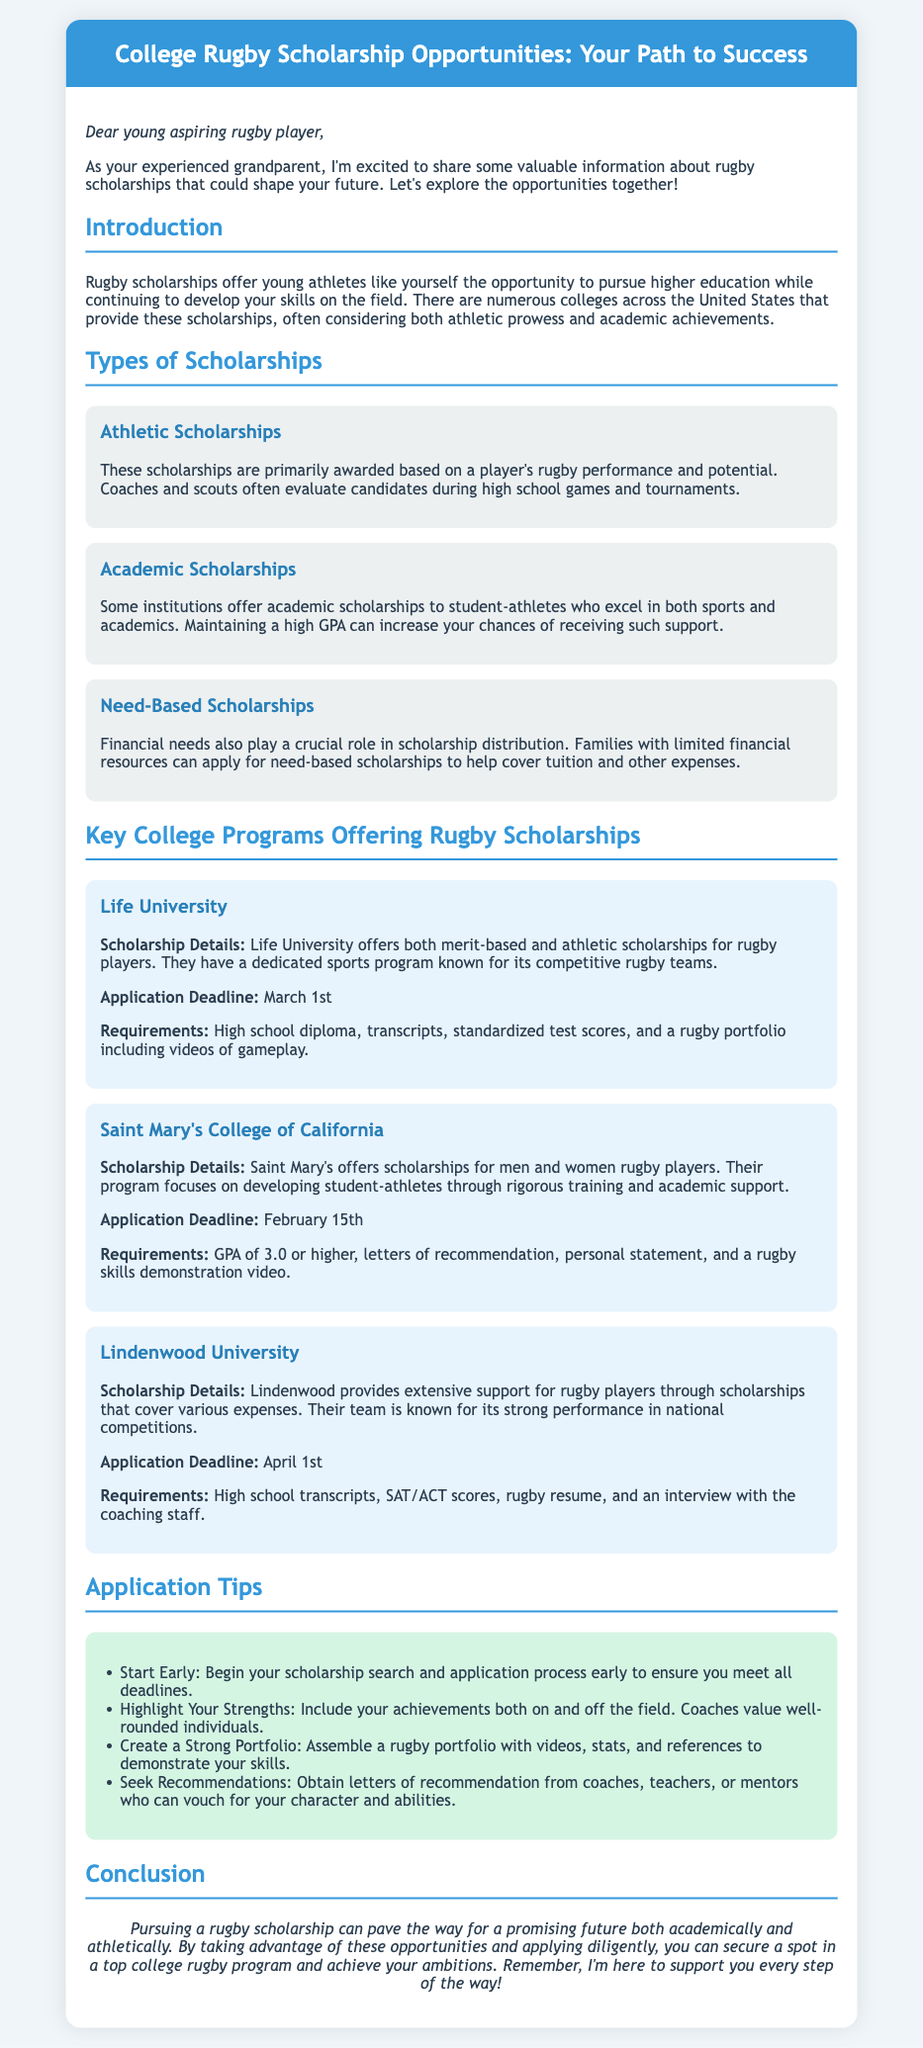What is the application deadline for Life University? The application deadline for Life University is mentioned in the document, specifically noted under the scholarship details.
Answer: March 1st What type of scholarships does Saint Mary's College of California offer? The document outlines different types of scholarships under the college program sections, and it specifies that Saint Mary's College offers scholarships for rugby players.
Answer: Rugby scholarships What are the requirements for Lindenwood University? The document states various requirements for Lindenwood University under its scholarship details, including necessary documents.
Answer: High school transcripts, SAT/ACT scores, rugby resume, and an interview How many types of scholarships are mentioned in the document? The document lists various types of scholarships under the "Types of Scholarships" section, which can be counted.
Answer: Three Which college has a scholarship application deadline of April 1st? The document specifies deadlines for several colleges under their scholarship details, leading to a specific college name.
Answer: Lindenwood University What GPA is required for academic scholarships at Saint Mary's College? The required GPA for receiving academic scholarships is mentioned under the college's requirements section.
Answer: 3.0 or higher What does the document suggest for creating a strong portfolio? The document offers application tips, highlighting the importance of portfolios.
Answer: Assemble a rugby portfolio with videos, stats, and references Which type of scholarship considers financial needs? The document explains the types of scholarships and identifies the one that focuses on financial considerations.
Answer: Need-Based Scholarships 